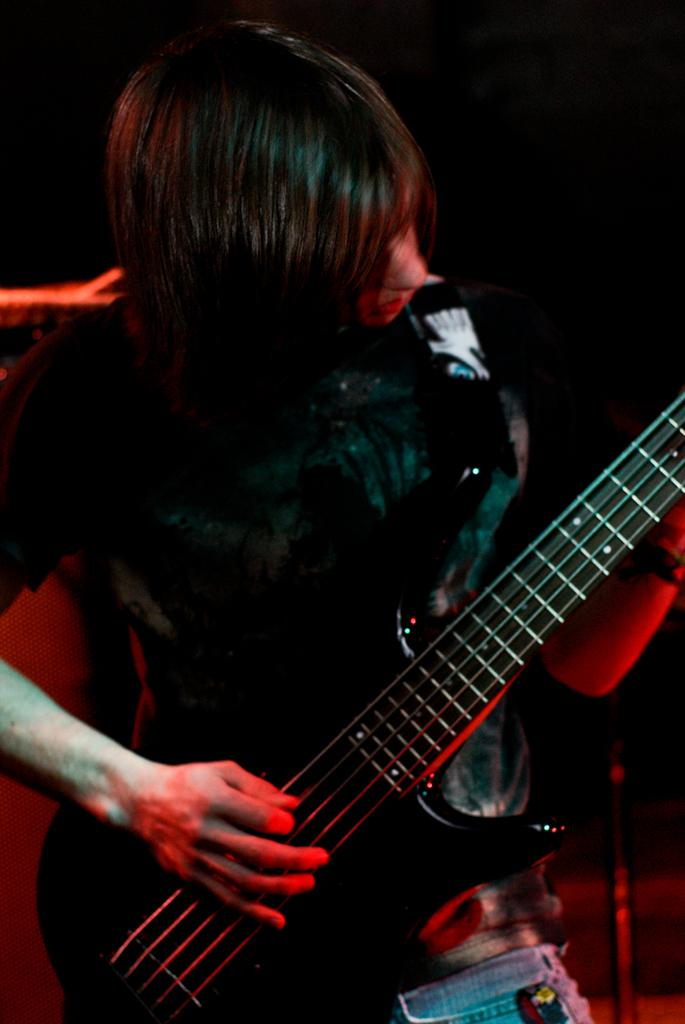Who is the main subject in the image? There is a woman in the image. What is the woman doing in the image? The woman is playing a guitar. Can you describe the guitar in the image? The guitar is black. What is the color of the background in the image? The background of the image is dark. What type of cake can be seen on the edge of the image? There is no cake present in the image. Is there a cactus visible in the background of the image? There is no cactus present in the image. 